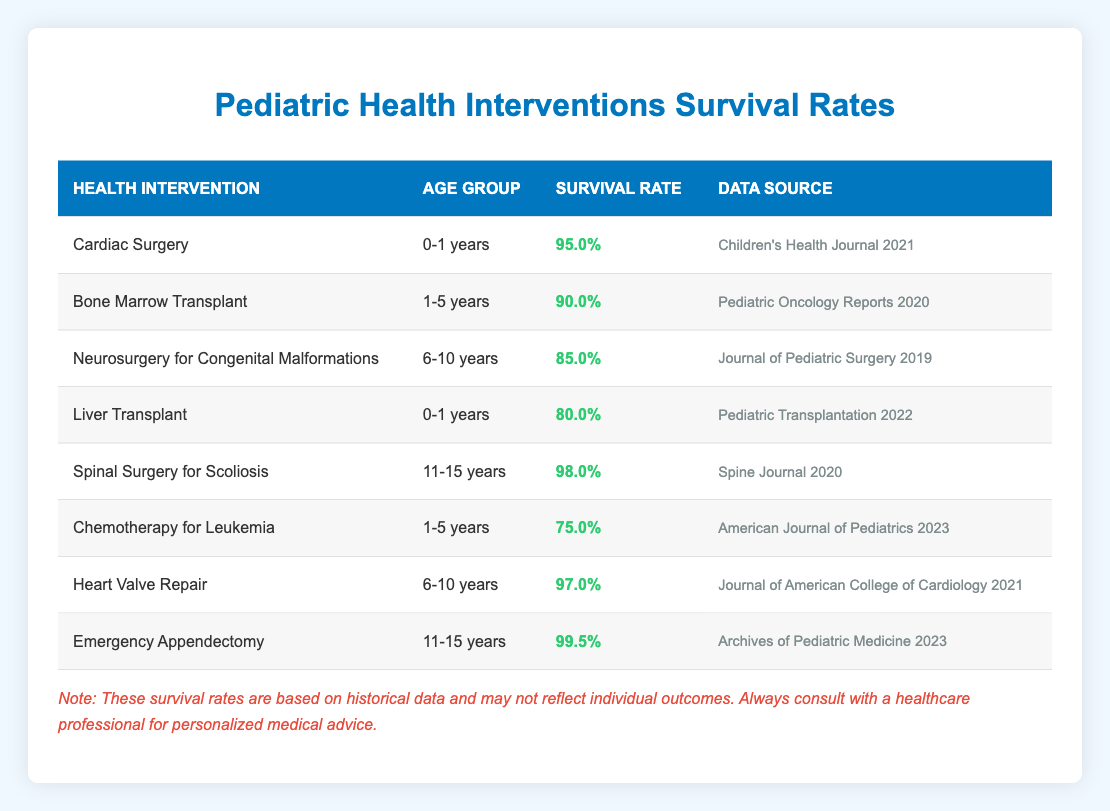What is the survival rate for children undergoing Cardiac Surgery between the ages of 0-1 years? The table shows a dedicated row for "Cardiac Surgery" under the "0-1 years" age group, where the survival rate is clearly indicated as 95.0%.
Answer: 95.0% What is the lowest survival rate among the health interventions listed? By examining all the survival rates for each health intervention, the lowest rate is found under "Chemotherapy for Leukemia" for the "1-5 years" age group with a survival rate of 75.0%.
Answer: 75.0% Is the survival rate for Liver Transplant lower than that for Bone Marrow Transplant? Comparing the two specific survival rates, Liver Transplant has a survival rate of 80.0%, while Bone Marrow Transplant has a higher survival rate of 90.0%. Therefore, the statement is true.
Answer: Yes What is the average survival rate for interventions in the age group of 6-10 years? The relevant interventions for this age group are "Neurosurgery for Congenital Malformations" (85.0%) and "Heart Valve Repair" (97.0%). To find the average, sum up these rates (85.0 + 97.0 = 182.0) and divide by 2, resulting in an average of 91.0%.
Answer: 91.0% Which health intervention has the highest survival rate, and what is that rate? Reviewing all the survival rates, the highest is found for "Emergency Appendectomy" in the "11-15 years" age group, with a survival rate of 99.5%.
Answer: 99.5% Are there any survival rates above 90% for the age group 11-15 years? The interventions for this age group are "Spinal Surgery for Scoliosis" (98.0%) and "Emergency Appendectomy" (99.5%). Both these rates are above 90%, confirming the existence of such rates.
Answer: Yes What is the difference in survival rates between Cardiac Surgery and Liver Transplant for the age group 0-1 years? The survival rate for Cardiac Surgery is 95.0% while for Liver Transplant it is 80.0%. The difference is calculated as 95.0% - 80.0% = 15.0%.
Answer: 15.0% What percentage of children survive following Chemotherapy for Leukemia in the 1-5 years age group? The table indicates that for Chemotherapy for Leukemia in the age group of 1-5 years, the survival rate is specifically stated as 75.0%.
Answer: 75.0% 